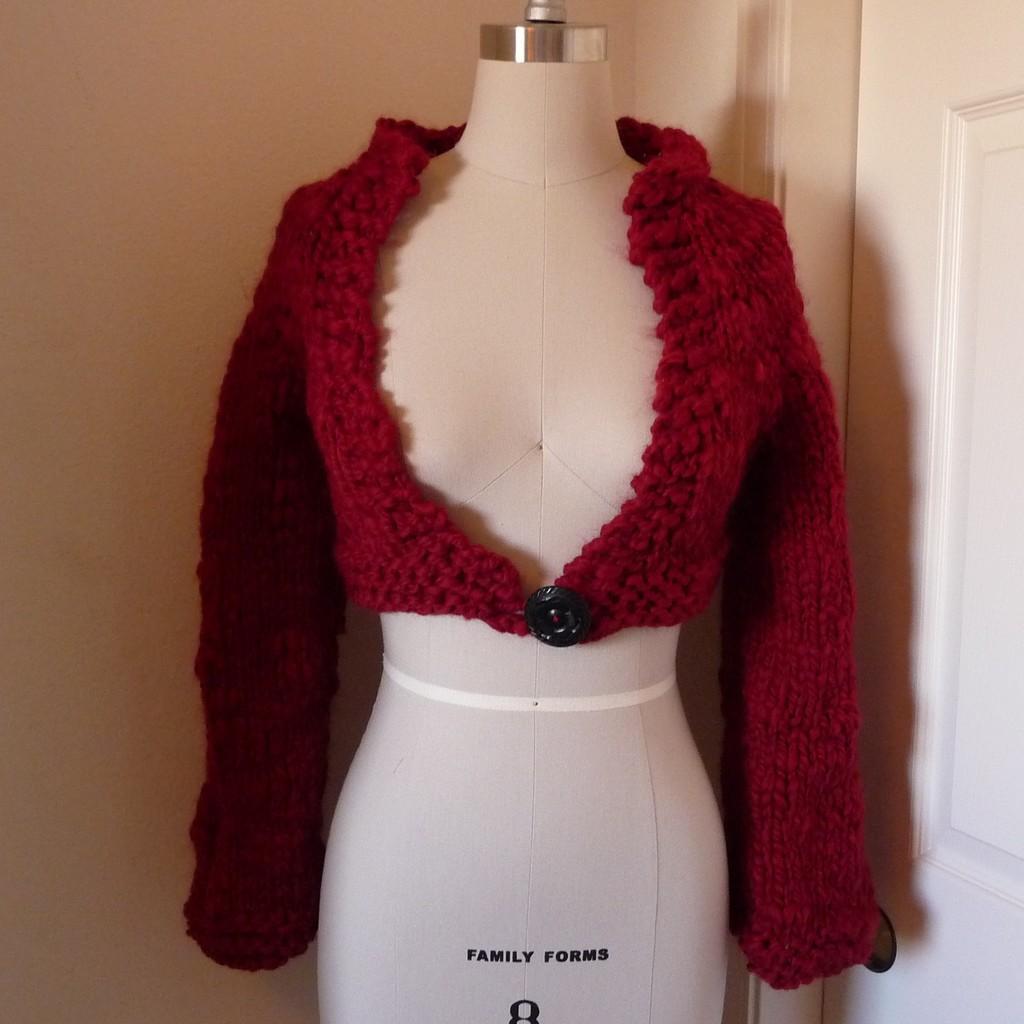Could you give a brief overview of what you see in this image? Here I can see a red color jacket to a mannequin. On the right side there is a white color door. In the background, I can see the wall. 